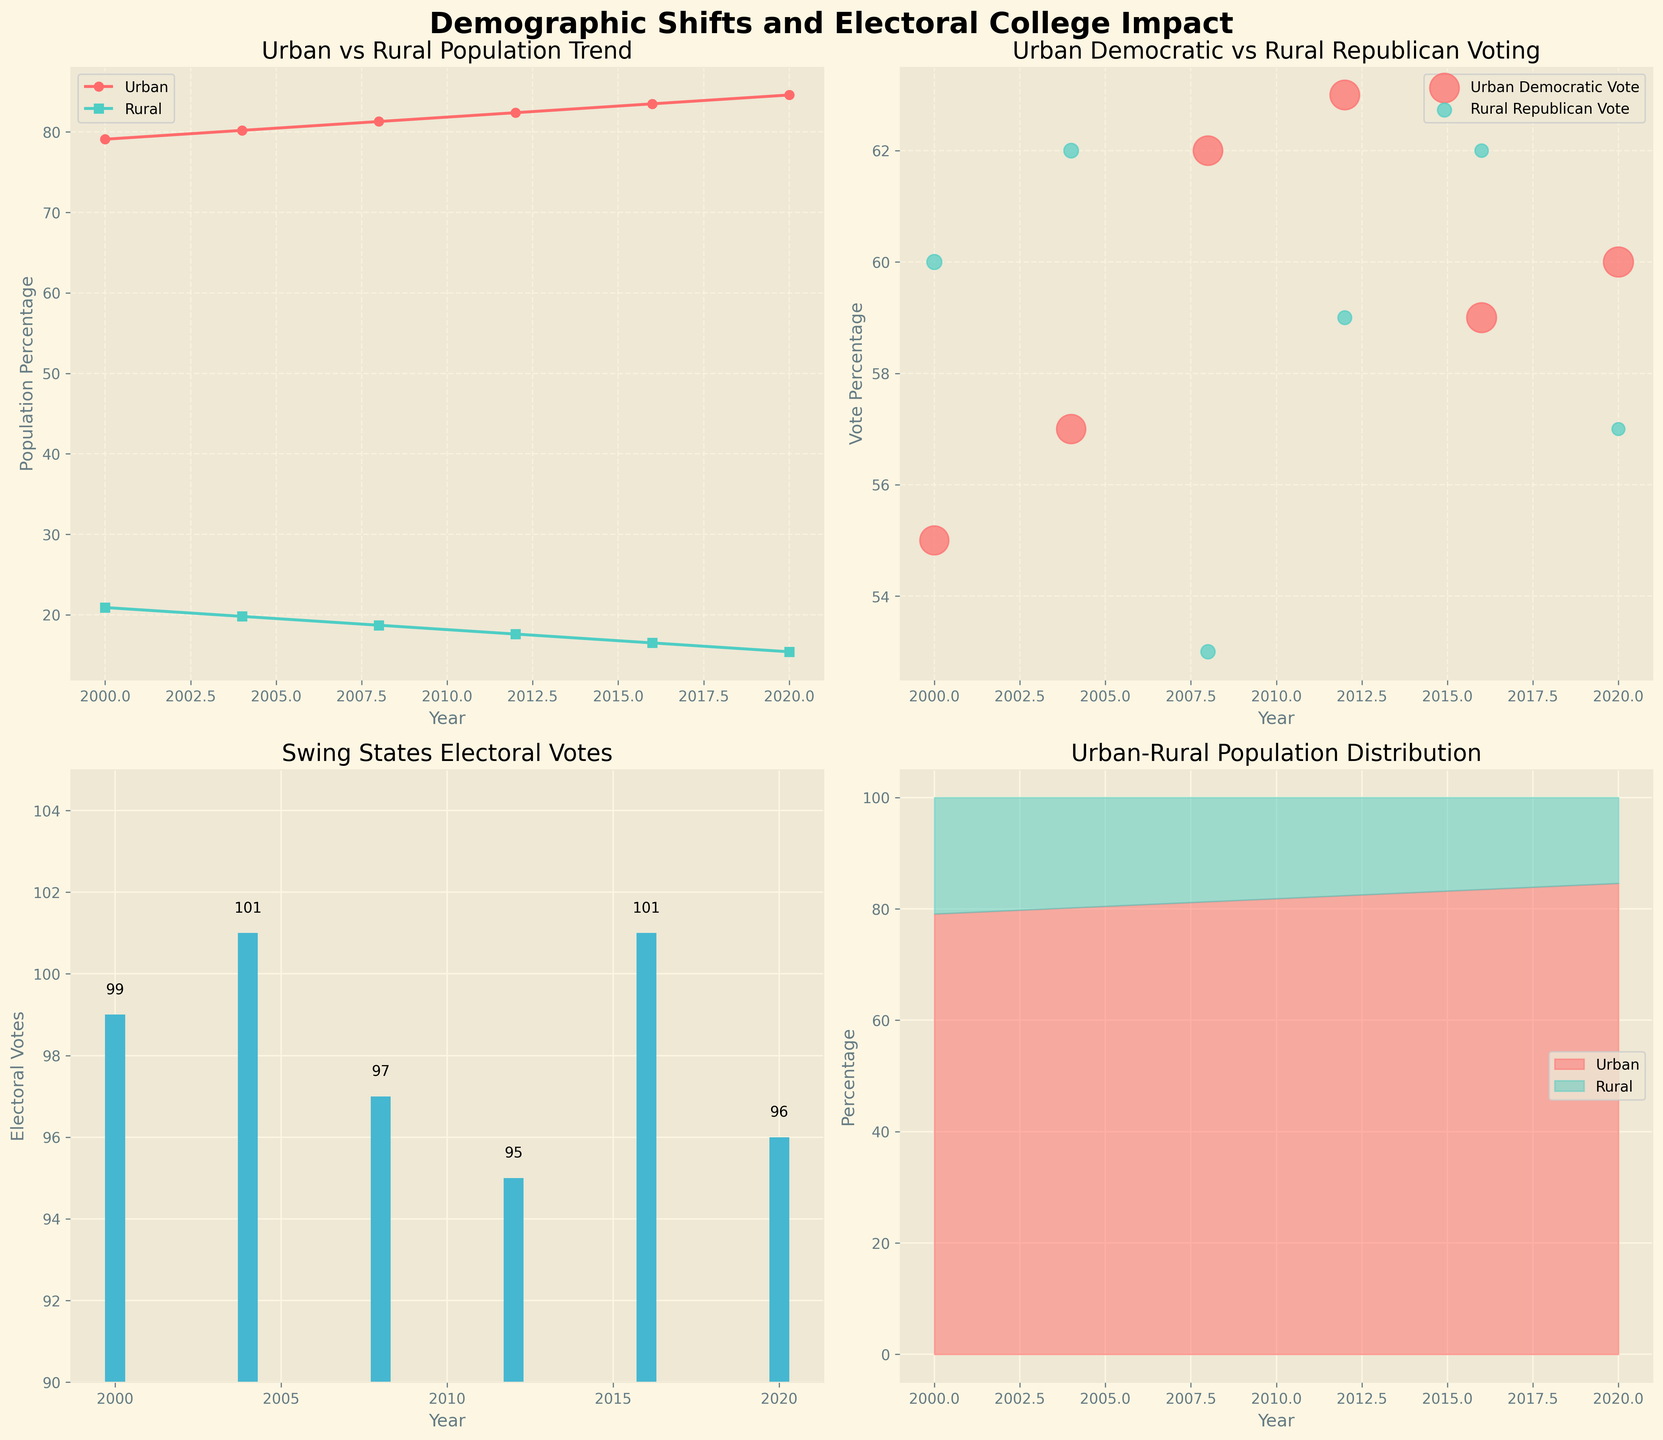What's the title of the entire figure? The main title is the text at the top of the figure. It provides a summary of what the figure is about.
Answer: Demographic Shifts and Electoral College Impact What trend can be observed in the urban population percentage between 2000 and 2020? Look at the line plot in the top-left subplot labeled 'Urban vs Rural Population Trend'. Follow the red line that represents the urban population percentage from 2000 to 2020.
Answer: It increased steadily How does the rural population percentage change over the years? Observe the green line in the top-left subplot. It shows the rural population percentage from 2000 to 2020.
Answer: It decreased steadily What is the approximate percentage of the urban population in 2012? In the top-left subplot, locate the year 2012 on the x-axis and follow it to the red line. The value on the y-axis represents the percentage.
Answer: Approximately 82.4% Which year had the highest electoral votes from swing states? In the bottom-left subplot labeled 'Swing States Electoral Votes', compare the heights of the bars for each year to identify the highest one.
Answer: 2004 In which year did Urban Democratic votes peak, and what was the percentage? Look at the scattered red dots in the top-right subplot. Identify the highest point and corresponding year on the x-axis.
Answer: 2012, 63% How do the urban votes compare to rural votes in 2016? In the top-right subplot, compare the red and green scatter points for the year 2016 to see which one is higher.
Answer: Urban votes: 59%, Rural votes: 62% What can be said about the relationship between urban population percentage and Urban Democratic votes over the years? Look at both the top-left subplot for urban population trends and the top-right subplot for Urban Democratic votes. Check if there is a correlation between urban growth and Democratic votes.
Answer: Both increased over time What is the average rural population percentage over the years? Add the rural percentages from each year and divide by the number of years (20.9, 19.8, 18.7, 17.6, 16.5, 15.4). Calculations: (20.9 + 19.8 + 18.7 + 17.6 + 16.5 + 15.4)/6 = 18.15
Answer: 18.15% 